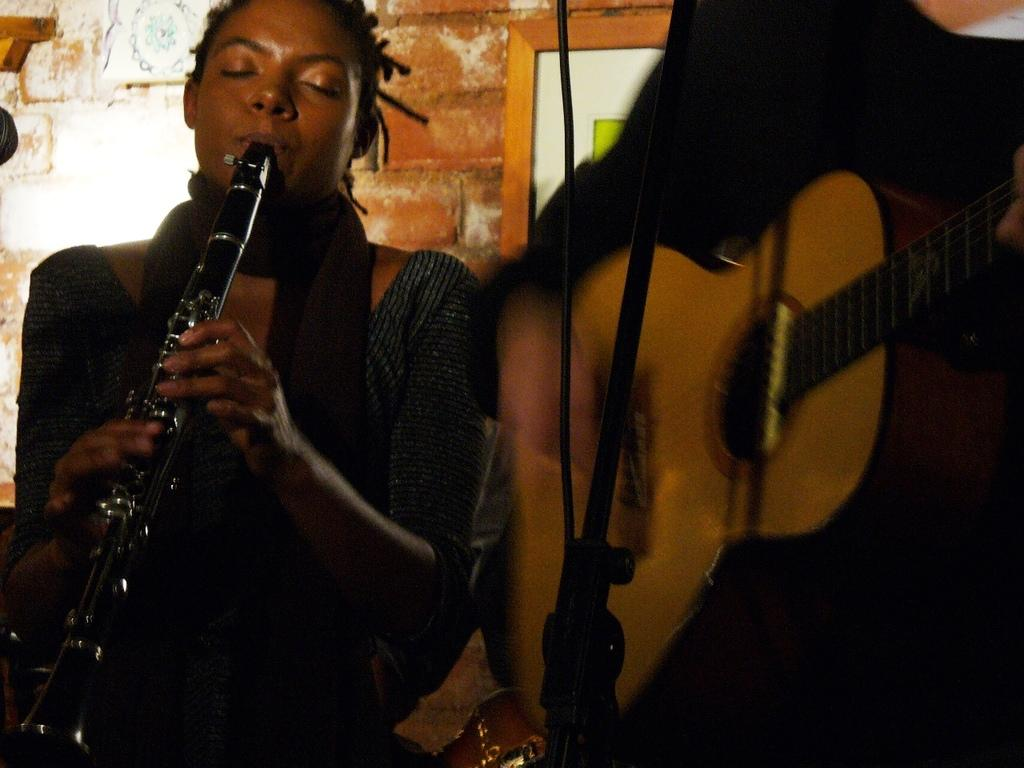What are the people in the image doing? The people in the image are playing musical instruments. What type of structure can be seen in the background of the image? There is a brick wall in the image. Can you describe any other objects in the image? Yes, there is a photo frame in the image. How does the jam help the people play their instruments in the image? There is no jam present in the image, and it does not have any role in the people playing their instruments. 